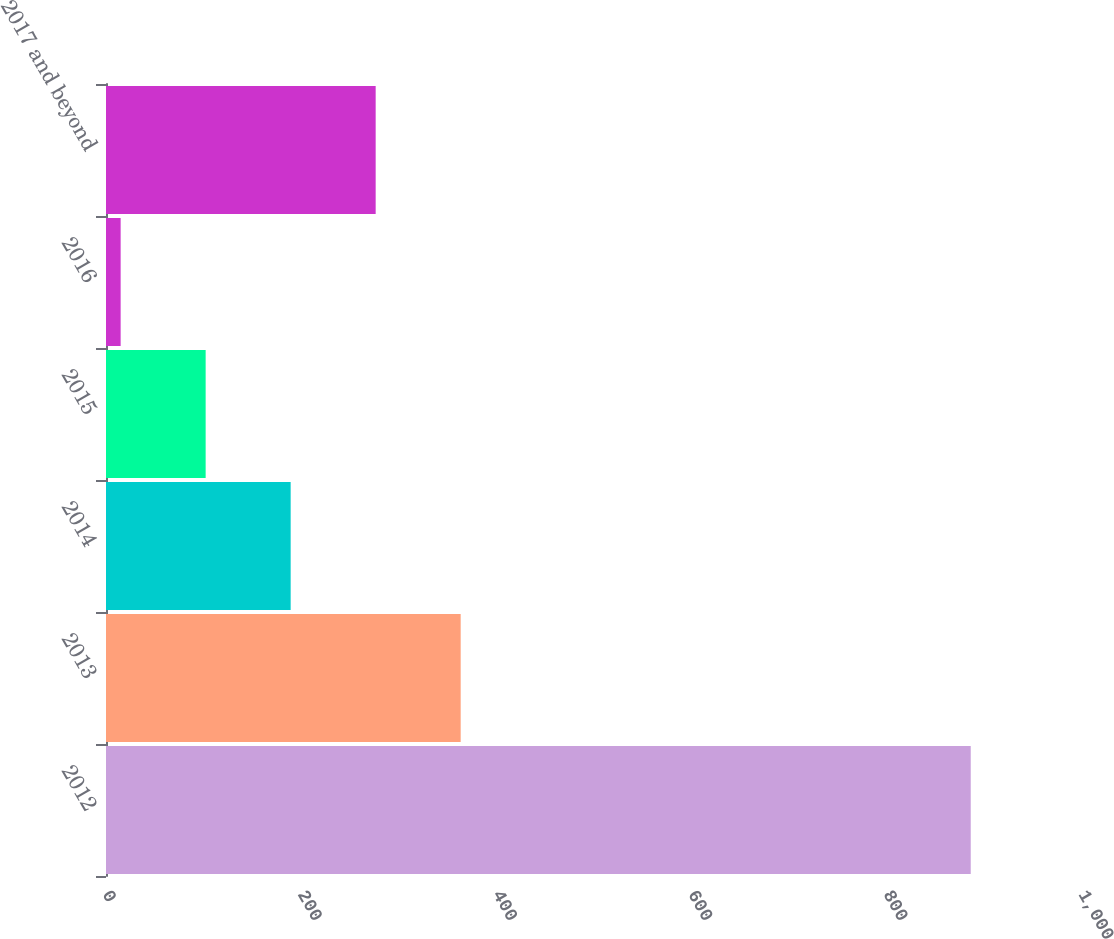<chart> <loc_0><loc_0><loc_500><loc_500><bar_chart><fcel>2012<fcel>2013<fcel>2014<fcel>2015<fcel>2016<fcel>2017 and beyond<nl><fcel>886<fcel>363.4<fcel>189.2<fcel>102.1<fcel>15<fcel>276.3<nl></chart> 